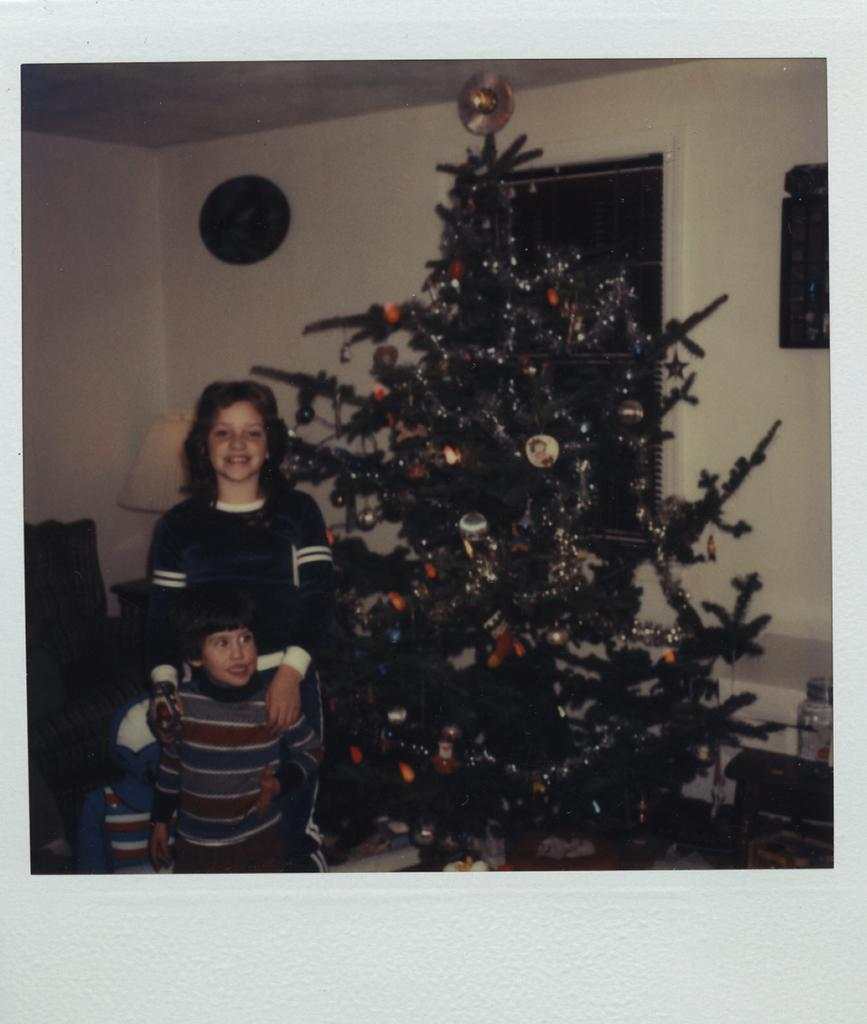What type of natural element is present in the image? There is a tree in the image. How many children are visible in the image? There are two children standing in the image. What is the object on the wall in the image? The object on the wall is a lamp. Can you tell me how many ducks are flying in the image? There are no ducks present in the image; it features a tree, two children, and a lamp on the wall. What type of calendar is hanging on the wall next to the lamp? There is no calendar present in the image; only the tree, two children, and the lamp are visible. 